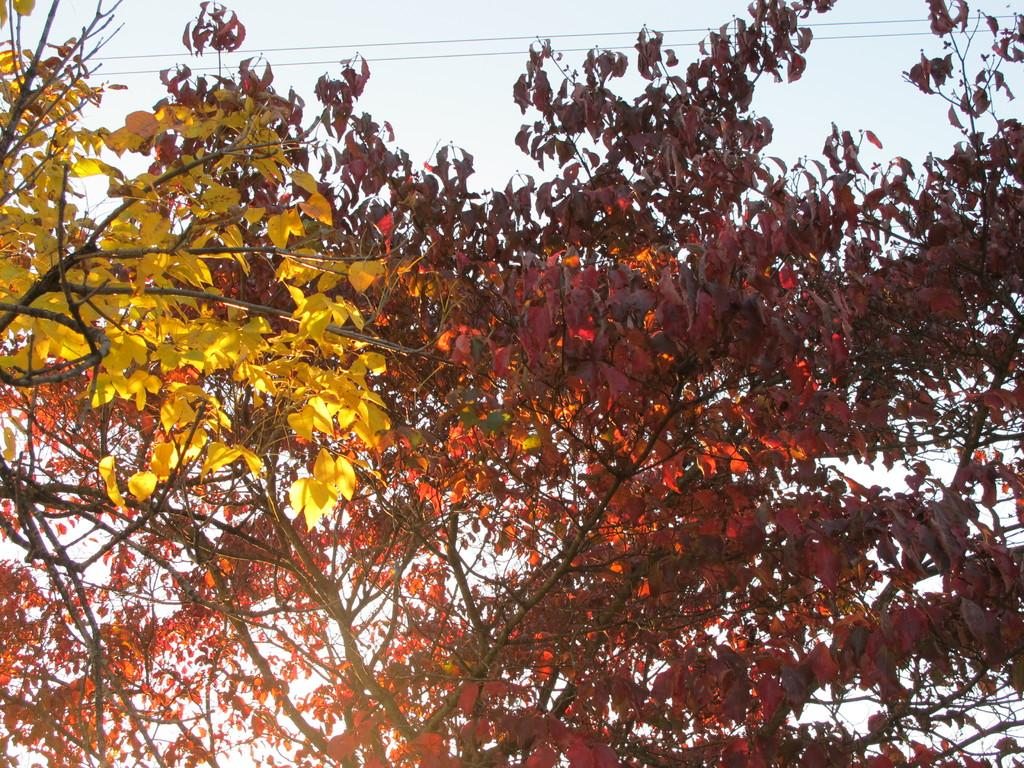What type of vegetation can be seen in the image? There are trees in the image. What is visible in the background of the image? The sky is visible in the background of the image. What else can be seen in the background of the image? There are cables in the background of the image. Can you tell me what the writer is doing in the image? There is no writer present in the image. Is there a crow perched on any of the trees in the image? There is no crow visible in the image. 